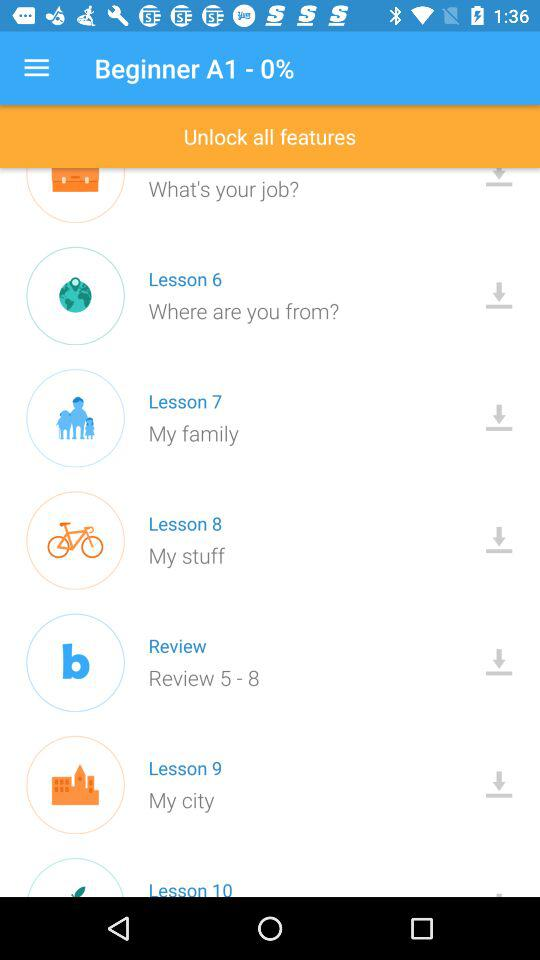Which lesson includes the question, "Where are you from?" The lesson is 6. 